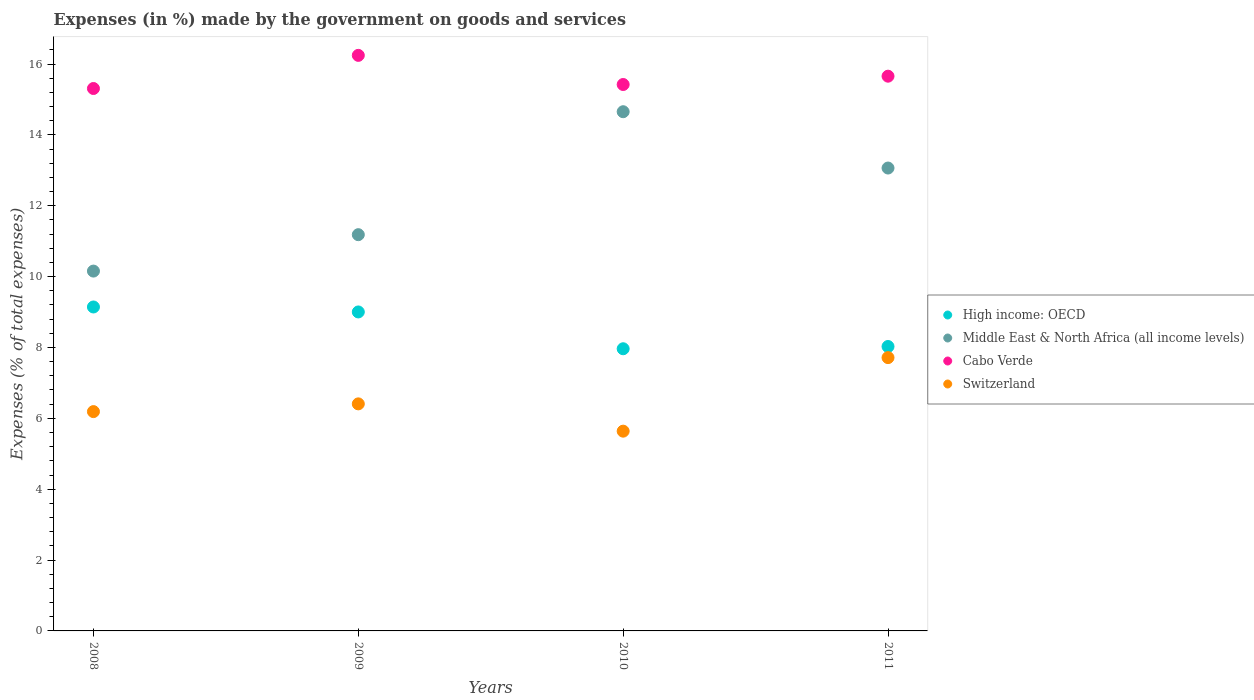What is the percentage of expenses made by the government on goods and services in Cabo Verde in 2010?
Your answer should be compact. 15.42. Across all years, what is the maximum percentage of expenses made by the government on goods and services in Middle East & North Africa (all income levels)?
Provide a succinct answer. 14.65. Across all years, what is the minimum percentage of expenses made by the government on goods and services in Cabo Verde?
Provide a succinct answer. 15.31. What is the total percentage of expenses made by the government on goods and services in Middle East & North Africa (all income levels) in the graph?
Make the answer very short. 49.06. What is the difference between the percentage of expenses made by the government on goods and services in Middle East & North Africa (all income levels) in 2008 and that in 2010?
Ensure brevity in your answer.  -4.5. What is the difference between the percentage of expenses made by the government on goods and services in High income: OECD in 2011 and the percentage of expenses made by the government on goods and services in Switzerland in 2008?
Your answer should be very brief. 1.84. What is the average percentage of expenses made by the government on goods and services in Middle East & North Africa (all income levels) per year?
Make the answer very short. 12.26. In the year 2011, what is the difference between the percentage of expenses made by the government on goods and services in High income: OECD and percentage of expenses made by the government on goods and services in Middle East & North Africa (all income levels)?
Provide a succinct answer. -5.04. In how many years, is the percentage of expenses made by the government on goods and services in Switzerland greater than 12.4 %?
Your response must be concise. 0. What is the ratio of the percentage of expenses made by the government on goods and services in Switzerland in 2008 to that in 2009?
Your response must be concise. 0.97. Is the percentage of expenses made by the government on goods and services in Cabo Verde in 2009 less than that in 2010?
Your answer should be compact. No. What is the difference between the highest and the second highest percentage of expenses made by the government on goods and services in Switzerland?
Make the answer very short. 1.31. What is the difference between the highest and the lowest percentage of expenses made by the government on goods and services in Cabo Verde?
Your answer should be very brief. 0.94. Is it the case that in every year, the sum of the percentage of expenses made by the government on goods and services in Middle East & North Africa (all income levels) and percentage of expenses made by the government on goods and services in Cabo Verde  is greater than the sum of percentage of expenses made by the government on goods and services in High income: OECD and percentage of expenses made by the government on goods and services in Switzerland?
Make the answer very short. Yes. Is it the case that in every year, the sum of the percentage of expenses made by the government on goods and services in High income: OECD and percentage of expenses made by the government on goods and services in Middle East & North Africa (all income levels)  is greater than the percentage of expenses made by the government on goods and services in Switzerland?
Offer a terse response. Yes. Does the percentage of expenses made by the government on goods and services in Cabo Verde monotonically increase over the years?
Keep it short and to the point. No. Is the percentage of expenses made by the government on goods and services in Cabo Verde strictly less than the percentage of expenses made by the government on goods and services in Switzerland over the years?
Provide a succinct answer. No. How many years are there in the graph?
Your response must be concise. 4. What is the difference between two consecutive major ticks on the Y-axis?
Offer a terse response. 2. Are the values on the major ticks of Y-axis written in scientific E-notation?
Your response must be concise. No. How many legend labels are there?
Provide a succinct answer. 4. What is the title of the graph?
Offer a terse response. Expenses (in %) made by the government on goods and services. Does "North America" appear as one of the legend labels in the graph?
Your answer should be very brief. No. What is the label or title of the Y-axis?
Your answer should be compact. Expenses (% of total expenses). What is the Expenses (% of total expenses) of High income: OECD in 2008?
Provide a succinct answer. 9.14. What is the Expenses (% of total expenses) of Middle East & North Africa (all income levels) in 2008?
Make the answer very short. 10.16. What is the Expenses (% of total expenses) in Cabo Verde in 2008?
Keep it short and to the point. 15.31. What is the Expenses (% of total expenses) in Switzerland in 2008?
Keep it short and to the point. 6.19. What is the Expenses (% of total expenses) of High income: OECD in 2009?
Provide a short and direct response. 9. What is the Expenses (% of total expenses) of Middle East & North Africa (all income levels) in 2009?
Provide a succinct answer. 11.18. What is the Expenses (% of total expenses) of Cabo Verde in 2009?
Offer a very short reply. 16.24. What is the Expenses (% of total expenses) in Switzerland in 2009?
Offer a terse response. 6.41. What is the Expenses (% of total expenses) of High income: OECD in 2010?
Your answer should be compact. 7.96. What is the Expenses (% of total expenses) of Middle East & North Africa (all income levels) in 2010?
Offer a terse response. 14.65. What is the Expenses (% of total expenses) in Cabo Verde in 2010?
Offer a terse response. 15.42. What is the Expenses (% of total expenses) in Switzerland in 2010?
Provide a short and direct response. 5.64. What is the Expenses (% of total expenses) in High income: OECD in 2011?
Your response must be concise. 8.03. What is the Expenses (% of total expenses) of Middle East & North Africa (all income levels) in 2011?
Give a very brief answer. 13.06. What is the Expenses (% of total expenses) in Cabo Verde in 2011?
Make the answer very short. 15.66. What is the Expenses (% of total expenses) in Switzerland in 2011?
Provide a short and direct response. 7.71. Across all years, what is the maximum Expenses (% of total expenses) in High income: OECD?
Ensure brevity in your answer.  9.14. Across all years, what is the maximum Expenses (% of total expenses) of Middle East & North Africa (all income levels)?
Your answer should be compact. 14.65. Across all years, what is the maximum Expenses (% of total expenses) in Cabo Verde?
Make the answer very short. 16.24. Across all years, what is the maximum Expenses (% of total expenses) of Switzerland?
Offer a terse response. 7.71. Across all years, what is the minimum Expenses (% of total expenses) in High income: OECD?
Your response must be concise. 7.96. Across all years, what is the minimum Expenses (% of total expenses) in Middle East & North Africa (all income levels)?
Provide a succinct answer. 10.16. Across all years, what is the minimum Expenses (% of total expenses) in Cabo Verde?
Your answer should be compact. 15.31. Across all years, what is the minimum Expenses (% of total expenses) of Switzerland?
Your response must be concise. 5.64. What is the total Expenses (% of total expenses) of High income: OECD in the graph?
Your response must be concise. 34.14. What is the total Expenses (% of total expenses) of Middle East & North Africa (all income levels) in the graph?
Your answer should be compact. 49.06. What is the total Expenses (% of total expenses) of Cabo Verde in the graph?
Ensure brevity in your answer.  62.63. What is the total Expenses (% of total expenses) of Switzerland in the graph?
Your answer should be compact. 25.95. What is the difference between the Expenses (% of total expenses) in High income: OECD in 2008 and that in 2009?
Give a very brief answer. 0.14. What is the difference between the Expenses (% of total expenses) in Middle East & North Africa (all income levels) in 2008 and that in 2009?
Give a very brief answer. -1.03. What is the difference between the Expenses (% of total expenses) of Cabo Verde in 2008 and that in 2009?
Make the answer very short. -0.94. What is the difference between the Expenses (% of total expenses) of Switzerland in 2008 and that in 2009?
Provide a short and direct response. -0.22. What is the difference between the Expenses (% of total expenses) in High income: OECD in 2008 and that in 2010?
Make the answer very short. 1.18. What is the difference between the Expenses (% of total expenses) in Middle East & North Africa (all income levels) in 2008 and that in 2010?
Make the answer very short. -4.5. What is the difference between the Expenses (% of total expenses) in Cabo Verde in 2008 and that in 2010?
Offer a very short reply. -0.11. What is the difference between the Expenses (% of total expenses) of Switzerland in 2008 and that in 2010?
Keep it short and to the point. 0.55. What is the difference between the Expenses (% of total expenses) in High income: OECD in 2008 and that in 2011?
Keep it short and to the point. 1.12. What is the difference between the Expenses (% of total expenses) of Middle East & North Africa (all income levels) in 2008 and that in 2011?
Make the answer very short. -2.91. What is the difference between the Expenses (% of total expenses) in Cabo Verde in 2008 and that in 2011?
Provide a short and direct response. -0.35. What is the difference between the Expenses (% of total expenses) in Switzerland in 2008 and that in 2011?
Ensure brevity in your answer.  -1.52. What is the difference between the Expenses (% of total expenses) in High income: OECD in 2009 and that in 2010?
Offer a terse response. 1.04. What is the difference between the Expenses (% of total expenses) in Middle East & North Africa (all income levels) in 2009 and that in 2010?
Ensure brevity in your answer.  -3.47. What is the difference between the Expenses (% of total expenses) in Cabo Verde in 2009 and that in 2010?
Offer a very short reply. 0.82. What is the difference between the Expenses (% of total expenses) in Switzerland in 2009 and that in 2010?
Your answer should be very brief. 0.77. What is the difference between the Expenses (% of total expenses) of High income: OECD in 2009 and that in 2011?
Your response must be concise. 0.98. What is the difference between the Expenses (% of total expenses) in Middle East & North Africa (all income levels) in 2009 and that in 2011?
Provide a succinct answer. -1.88. What is the difference between the Expenses (% of total expenses) in Cabo Verde in 2009 and that in 2011?
Your answer should be very brief. 0.59. What is the difference between the Expenses (% of total expenses) in Switzerland in 2009 and that in 2011?
Provide a short and direct response. -1.31. What is the difference between the Expenses (% of total expenses) in High income: OECD in 2010 and that in 2011?
Your answer should be very brief. -0.06. What is the difference between the Expenses (% of total expenses) in Middle East & North Africa (all income levels) in 2010 and that in 2011?
Provide a succinct answer. 1.59. What is the difference between the Expenses (% of total expenses) of Cabo Verde in 2010 and that in 2011?
Offer a terse response. -0.23. What is the difference between the Expenses (% of total expenses) of Switzerland in 2010 and that in 2011?
Give a very brief answer. -2.08. What is the difference between the Expenses (% of total expenses) in High income: OECD in 2008 and the Expenses (% of total expenses) in Middle East & North Africa (all income levels) in 2009?
Offer a terse response. -2.04. What is the difference between the Expenses (% of total expenses) in High income: OECD in 2008 and the Expenses (% of total expenses) in Cabo Verde in 2009?
Ensure brevity in your answer.  -7.1. What is the difference between the Expenses (% of total expenses) in High income: OECD in 2008 and the Expenses (% of total expenses) in Switzerland in 2009?
Provide a short and direct response. 2.73. What is the difference between the Expenses (% of total expenses) of Middle East & North Africa (all income levels) in 2008 and the Expenses (% of total expenses) of Cabo Verde in 2009?
Offer a very short reply. -6.09. What is the difference between the Expenses (% of total expenses) of Middle East & North Africa (all income levels) in 2008 and the Expenses (% of total expenses) of Switzerland in 2009?
Provide a succinct answer. 3.75. What is the difference between the Expenses (% of total expenses) in Cabo Verde in 2008 and the Expenses (% of total expenses) in Switzerland in 2009?
Your answer should be very brief. 8.9. What is the difference between the Expenses (% of total expenses) of High income: OECD in 2008 and the Expenses (% of total expenses) of Middle East & North Africa (all income levels) in 2010?
Offer a very short reply. -5.51. What is the difference between the Expenses (% of total expenses) in High income: OECD in 2008 and the Expenses (% of total expenses) in Cabo Verde in 2010?
Provide a short and direct response. -6.28. What is the difference between the Expenses (% of total expenses) of High income: OECD in 2008 and the Expenses (% of total expenses) of Switzerland in 2010?
Give a very brief answer. 3.5. What is the difference between the Expenses (% of total expenses) in Middle East & North Africa (all income levels) in 2008 and the Expenses (% of total expenses) in Cabo Verde in 2010?
Give a very brief answer. -5.27. What is the difference between the Expenses (% of total expenses) in Middle East & North Africa (all income levels) in 2008 and the Expenses (% of total expenses) in Switzerland in 2010?
Your answer should be compact. 4.52. What is the difference between the Expenses (% of total expenses) in Cabo Verde in 2008 and the Expenses (% of total expenses) in Switzerland in 2010?
Your response must be concise. 9.67. What is the difference between the Expenses (% of total expenses) of High income: OECD in 2008 and the Expenses (% of total expenses) of Middle East & North Africa (all income levels) in 2011?
Your answer should be very brief. -3.92. What is the difference between the Expenses (% of total expenses) of High income: OECD in 2008 and the Expenses (% of total expenses) of Cabo Verde in 2011?
Provide a short and direct response. -6.51. What is the difference between the Expenses (% of total expenses) in High income: OECD in 2008 and the Expenses (% of total expenses) in Switzerland in 2011?
Offer a very short reply. 1.43. What is the difference between the Expenses (% of total expenses) in Middle East & North Africa (all income levels) in 2008 and the Expenses (% of total expenses) in Cabo Verde in 2011?
Your answer should be compact. -5.5. What is the difference between the Expenses (% of total expenses) in Middle East & North Africa (all income levels) in 2008 and the Expenses (% of total expenses) in Switzerland in 2011?
Keep it short and to the point. 2.44. What is the difference between the Expenses (% of total expenses) in Cabo Verde in 2008 and the Expenses (% of total expenses) in Switzerland in 2011?
Provide a short and direct response. 7.6. What is the difference between the Expenses (% of total expenses) in High income: OECD in 2009 and the Expenses (% of total expenses) in Middle East & North Africa (all income levels) in 2010?
Keep it short and to the point. -5.65. What is the difference between the Expenses (% of total expenses) of High income: OECD in 2009 and the Expenses (% of total expenses) of Cabo Verde in 2010?
Provide a succinct answer. -6.42. What is the difference between the Expenses (% of total expenses) in High income: OECD in 2009 and the Expenses (% of total expenses) in Switzerland in 2010?
Give a very brief answer. 3.36. What is the difference between the Expenses (% of total expenses) in Middle East & North Africa (all income levels) in 2009 and the Expenses (% of total expenses) in Cabo Verde in 2010?
Keep it short and to the point. -4.24. What is the difference between the Expenses (% of total expenses) in Middle East & North Africa (all income levels) in 2009 and the Expenses (% of total expenses) in Switzerland in 2010?
Ensure brevity in your answer.  5.55. What is the difference between the Expenses (% of total expenses) in Cabo Verde in 2009 and the Expenses (% of total expenses) in Switzerland in 2010?
Provide a succinct answer. 10.61. What is the difference between the Expenses (% of total expenses) in High income: OECD in 2009 and the Expenses (% of total expenses) in Middle East & North Africa (all income levels) in 2011?
Your answer should be very brief. -4.06. What is the difference between the Expenses (% of total expenses) in High income: OECD in 2009 and the Expenses (% of total expenses) in Cabo Verde in 2011?
Offer a terse response. -6.65. What is the difference between the Expenses (% of total expenses) in High income: OECD in 2009 and the Expenses (% of total expenses) in Switzerland in 2011?
Ensure brevity in your answer.  1.29. What is the difference between the Expenses (% of total expenses) in Middle East & North Africa (all income levels) in 2009 and the Expenses (% of total expenses) in Cabo Verde in 2011?
Make the answer very short. -4.47. What is the difference between the Expenses (% of total expenses) of Middle East & North Africa (all income levels) in 2009 and the Expenses (% of total expenses) of Switzerland in 2011?
Provide a short and direct response. 3.47. What is the difference between the Expenses (% of total expenses) in Cabo Verde in 2009 and the Expenses (% of total expenses) in Switzerland in 2011?
Provide a short and direct response. 8.53. What is the difference between the Expenses (% of total expenses) in High income: OECD in 2010 and the Expenses (% of total expenses) in Middle East & North Africa (all income levels) in 2011?
Keep it short and to the point. -5.1. What is the difference between the Expenses (% of total expenses) of High income: OECD in 2010 and the Expenses (% of total expenses) of Cabo Verde in 2011?
Ensure brevity in your answer.  -7.69. What is the difference between the Expenses (% of total expenses) in High income: OECD in 2010 and the Expenses (% of total expenses) in Switzerland in 2011?
Your answer should be compact. 0.25. What is the difference between the Expenses (% of total expenses) of Middle East & North Africa (all income levels) in 2010 and the Expenses (% of total expenses) of Cabo Verde in 2011?
Provide a short and direct response. -1. What is the difference between the Expenses (% of total expenses) in Middle East & North Africa (all income levels) in 2010 and the Expenses (% of total expenses) in Switzerland in 2011?
Make the answer very short. 6.94. What is the difference between the Expenses (% of total expenses) of Cabo Verde in 2010 and the Expenses (% of total expenses) of Switzerland in 2011?
Offer a very short reply. 7.71. What is the average Expenses (% of total expenses) of High income: OECD per year?
Your answer should be very brief. 8.53. What is the average Expenses (% of total expenses) of Middle East & North Africa (all income levels) per year?
Keep it short and to the point. 12.26. What is the average Expenses (% of total expenses) in Cabo Verde per year?
Ensure brevity in your answer.  15.66. What is the average Expenses (% of total expenses) in Switzerland per year?
Make the answer very short. 6.49. In the year 2008, what is the difference between the Expenses (% of total expenses) in High income: OECD and Expenses (% of total expenses) in Middle East & North Africa (all income levels)?
Provide a succinct answer. -1.01. In the year 2008, what is the difference between the Expenses (% of total expenses) of High income: OECD and Expenses (% of total expenses) of Cabo Verde?
Give a very brief answer. -6.17. In the year 2008, what is the difference between the Expenses (% of total expenses) in High income: OECD and Expenses (% of total expenses) in Switzerland?
Keep it short and to the point. 2.95. In the year 2008, what is the difference between the Expenses (% of total expenses) in Middle East & North Africa (all income levels) and Expenses (% of total expenses) in Cabo Verde?
Offer a very short reply. -5.15. In the year 2008, what is the difference between the Expenses (% of total expenses) of Middle East & North Africa (all income levels) and Expenses (% of total expenses) of Switzerland?
Make the answer very short. 3.97. In the year 2008, what is the difference between the Expenses (% of total expenses) of Cabo Verde and Expenses (% of total expenses) of Switzerland?
Your answer should be compact. 9.12. In the year 2009, what is the difference between the Expenses (% of total expenses) in High income: OECD and Expenses (% of total expenses) in Middle East & North Africa (all income levels)?
Your answer should be compact. -2.18. In the year 2009, what is the difference between the Expenses (% of total expenses) in High income: OECD and Expenses (% of total expenses) in Cabo Verde?
Keep it short and to the point. -7.24. In the year 2009, what is the difference between the Expenses (% of total expenses) of High income: OECD and Expenses (% of total expenses) of Switzerland?
Provide a succinct answer. 2.59. In the year 2009, what is the difference between the Expenses (% of total expenses) in Middle East & North Africa (all income levels) and Expenses (% of total expenses) in Cabo Verde?
Your answer should be very brief. -5.06. In the year 2009, what is the difference between the Expenses (% of total expenses) of Middle East & North Africa (all income levels) and Expenses (% of total expenses) of Switzerland?
Provide a short and direct response. 4.78. In the year 2009, what is the difference between the Expenses (% of total expenses) in Cabo Verde and Expenses (% of total expenses) in Switzerland?
Your answer should be very brief. 9.84. In the year 2010, what is the difference between the Expenses (% of total expenses) of High income: OECD and Expenses (% of total expenses) of Middle East & North Africa (all income levels)?
Offer a terse response. -6.69. In the year 2010, what is the difference between the Expenses (% of total expenses) in High income: OECD and Expenses (% of total expenses) in Cabo Verde?
Your answer should be very brief. -7.46. In the year 2010, what is the difference between the Expenses (% of total expenses) of High income: OECD and Expenses (% of total expenses) of Switzerland?
Provide a succinct answer. 2.33. In the year 2010, what is the difference between the Expenses (% of total expenses) of Middle East & North Africa (all income levels) and Expenses (% of total expenses) of Cabo Verde?
Give a very brief answer. -0.77. In the year 2010, what is the difference between the Expenses (% of total expenses) of Middle East & North Africa (all income levels) and Expenses (% of total expenses) of Switzerland?
Give a very brief answer. 9.02. In the year 2010, what is the difference between the Expenses (% of total expenses) in Cabo Verde and Expenses (% of total expenses) in Switzerland?
Offer a very short reply. 9.78. In the year 2011, what is the difference between the Expenses (% of total expenses) of High income: OECD and Expenses (% of total expenses) of Middle East & North Africa (all income levels)?
Keep it short and to the point. -5.04. In the year 2011, what is the difference between the Expenses (% of total expenses) in High income: OECD and Expenses (% of total expenses) in Cabo Verde?
Your answer should be compact. -7.63. In the year 2011, what is the difference between the Expenses (% of total expenses) of High income: OECD and Expenses (% of total expenses) of Switzerland?
Provide a succinct answer. 0.31. In the year 2011, what is the difference between the Expenses (% of total expenses) in Middle East & North Africa (all income levels) and Expenses (% of total expenses) in Cabo Verde?
Your answer should be compact. -2.59. In the year 2011, what is the difference between the Expenses (% of total expenses) in Middle East & North Africa (all income levels) and Expenses (% of total expenses) in Switzerland?
Your response must be concise. 5.35. In the year 2011, what is the difference between the Expenses (% of total expenses) of Cabo Verde and Expenses (% of total expenses) of Switzerland?
Your response must be concise. 7.94. What is the ratio of the Expenses (% of total expenses) of High income: OECD in 2008 to that in 2009?
Offer a very short reply. 1.02. What is the ratio of the Expenses (% of total expenses) in Middle East & North Africa (all income levels) in 2008 to that in 2009?
Offer a terse response. 0.91. What is the ratio of the Expenses (% of total expenses) in Cabo Verde in 2008 to that in 2009?
Provide a short and direct response. 0.94. What is the ratio of the Expenses (% of total expenses) in Switzerland in 2008 to that in 2009?
Provide a succinct answer. 0.97. What is the ratio of the Expenses (% of total expenses) in High income: OECD in 2008 to that in 2010?
Offer a very short reply. 1.15. What is the ratio of the Expenses (% of total expenses) in Middle East & North Africa (all income levels) in 2008 to that in 2010?
Make the answer very short. 0.69. What is the ratio of the Expenses (% of total expenses) of Cabo Verde in 2008 to that in 2010?
Make the answer very short. 0.99. What is the ratio of the Expenses (% of total expenses) of Switzerland in 2008 to that in 2010?
Your answer should be very brief. 1.1. What is the ratio of the Expenses (% of total expenses) of High income: OECD in 2008 to that in 2011?
Ensure brevity in your answer.  1.14. What is the ratio of the Expenses (% of total expenses) in Middle East & North Africa (all income levels) in 2008 to that in 2011?
Ensure brevity in your answer.  0.78. What is the ratio of the Expenses (% of total expenses) of Cabo Verde in 2008 to that in 2011?
Give a very brief answer. 0.98. What is the ratio of the Expenses (% of total expenses) of Switzerland in 2008 to that in 2011?
Offer a terse response. 0.8. What is the ratio of the Expenses (% of total expenses) in High income: OECD in 2009 to that in 2010?
Your response must be concise. 1.13. What is the ratio of the Expenses (% of total expenses) in Middle East & North Africa (all income levels) in 2009 to that in 2010?
Your response must be concise. 0.76. What is the ratio of the Expenses (% of total expenses) of Cabo Verde in 2009 to that in 2010?
Keep it short and to the point. 1.05. What is the ratio of the Expenses (% of total expenses) of Switzerland in 2009 to that in 2010?
Provide a short and direct response. 1.14. What is the ratio of the Expenses (% of total expenses) in High income: OECD in 2009 to that in 2011?
Ensure brevity in your answer.  1.12. What is the ratio of the Expenses (% of total expenses) in Middle East & North Africa (all income levels) in 2009 to that in 2011?
Give a very brief answer. 0.86. What is the ratio of the Expenses (% of total expenses) of Cabo Verde in 2009 to that in 2011?
Your answer should be compact. 1.04. What is the ratio of the Expenses (% of total expenses) of Switzerland in 2009 to that in 2011?
Your answer should be compact. 0.83. What is the ratio of the Expenses (% of total expenses) in Middle East & North Africa (all income levels) in 2010 to that in 2011?
Make the answer very short. 1.12. What is the ratio of the Expenses (% of total expenses) in Switzerland in 2010 to that in 2011?
Keep it short and to the point. 0.73. What is the difference between the highest and the second highest Expenses (% of total expenses) in High income: OECD?
Provide a succinct answer. 0.14. What is the difference between the highest and the second highest Expenses (% of total expenses) in Middle East & North Africa (all income levels)?
Ensure brevity in your answer.  1.59. What is the difference between the highest and the second highest Expenses (% of total expenses) of Cabo Verde?
Make the answer very short. 0.59. What is the difference between the highest and the second highest Expenses (% of total expenses) of Switzerland?
Your answer should be compact. 1.31. What is the difference between the highest and the lowest Expenses (% of total expenses) of High income: OECD?
Make the answer very short. 1.18. What is the difference between the highest and the lowest Expenses (% of total expenses) in Middle East & North Africa (all income levels)?
Offer a very short reply. 4.5. What is the difference between the highest and the lowest Expenses (% of total expenses) of Cabo Verde?
Your response must be concise. 0.94. What is the difference between the highest and the lowest Expenses (% of total expenses) of Switzerland?
Make the answer very short. 2.08. 